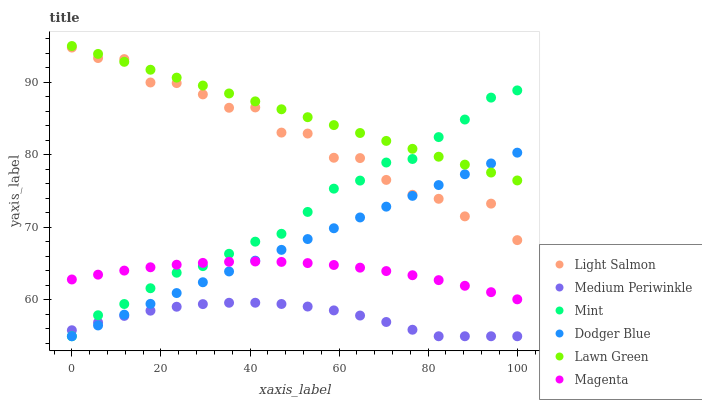Does Medium Periwinkle have the minimum area under the curve?
Answer yes or no. Yes. Does Lawn Green have the maximum area under the curve?
Answer yes or no. Yes. Does Light Salmon have the minimum area under the curve?
Answer yes or no. No. Does Light Salmon have the maximum area under the curve?
Answer yes or no. No. Is Lawn Green the smoothest?
Answer yes or no. Yes. Is Light Salmon the roughest?
Answer yes or no. Yes. Is Medium Periwinkle the smoothest?
Answer yes or no. No. Is Medium Periwinkle the roughest?
Answer yes or no. No. Does Medium Periwinkle have the lowest value?
Answer yes or no. Yes. Does Light Salmon have the lowest value?
Answer yes or no. No. Does Lawn Green have the highest value?
Answer yes or no. Yes. Does Light Salmon have the highest value?
Answer yes or no. No. Is Medium Periwinkle less than Light Salmon?
Answer yes or no. Yes. Is Light Salmon greater than Medium Periwinkle?
Answer yes or no. Yes. Does Dodger Blue intersect Lawn Green?
Answer yes or no. Yes. Is Dodger Blue less than Lawn Green?
Answer yes or no. No. Is Dodger Blue greater than Lawn Green?
Answer yes or no. No. Does Medium Periwinkle intersect Light Salmon?
Answer yes or no. No. 